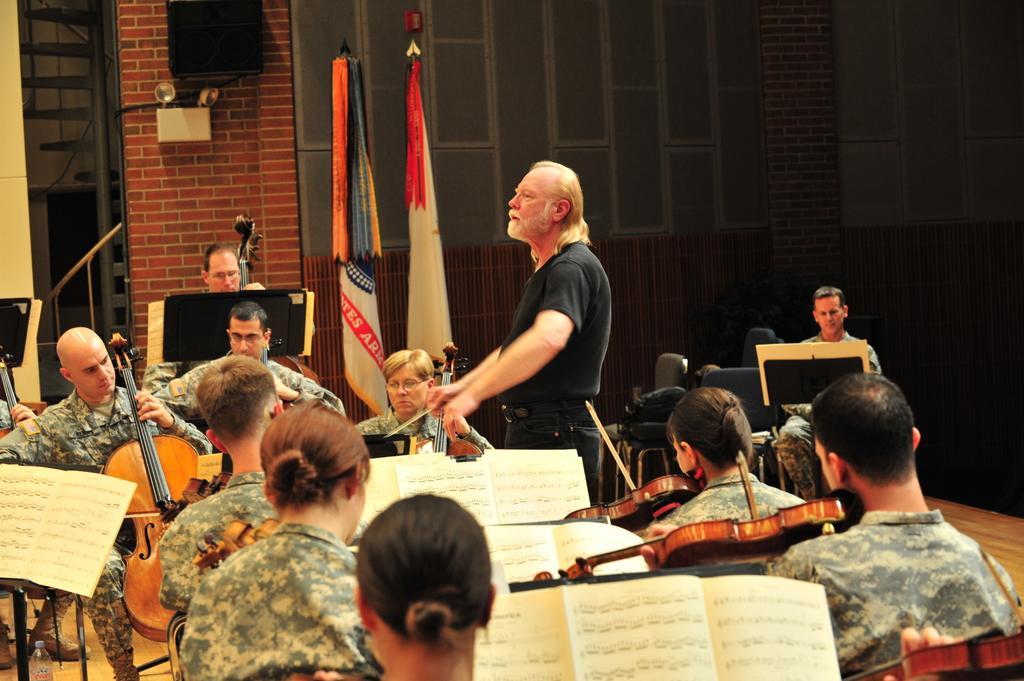Describe this image in one or two sentences. In this image, there are group of people sitting on the chair and playing guitar. In the middle, a person is standing and guiding others. The background wall is grey and brown in color. In the middle, two flags are kept. This image is taken inside a hall. 